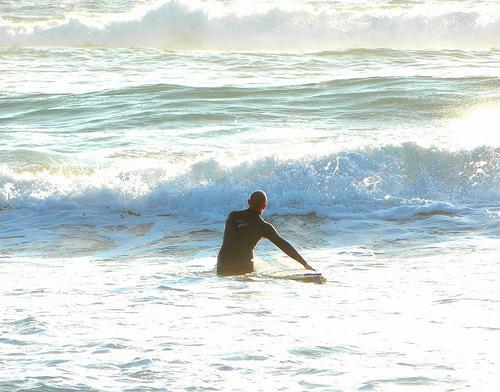How many people are there?
Give a very brief answer. 1. 